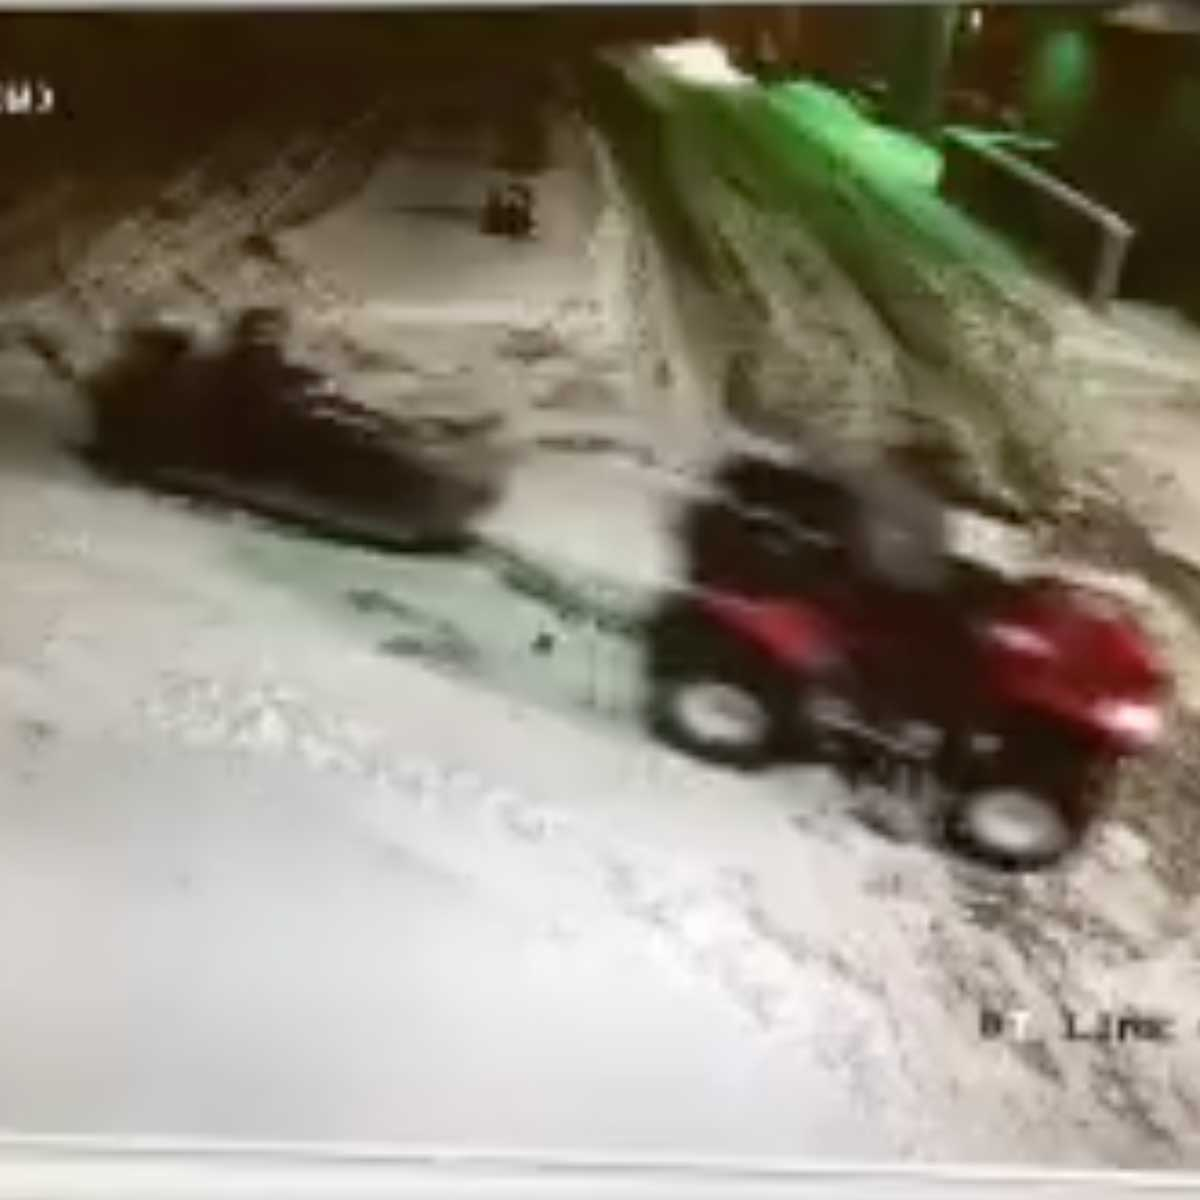What can you infer about the driving skills required to operate the ATV in these conditions? Operating an ATV in these snowy and potentially icy conditions demands a high level of skill and experience. The driver must be adept at navigating difficult terrain, maintaining control on slippery surfaces, and quickly reacting to obstacles that might be hidden under the snow. Knowledge of how to maneuver the vehicle to avoid skidding and familiarity with the vehicle’s handling characteristics in low-traction conditions are crucial. Additionally, the driver should have experience with night or low-light driving if the scene is set during such conditions. Overall, it requires a combination of technical driving skills, quick reflexes, and situational awareness. 